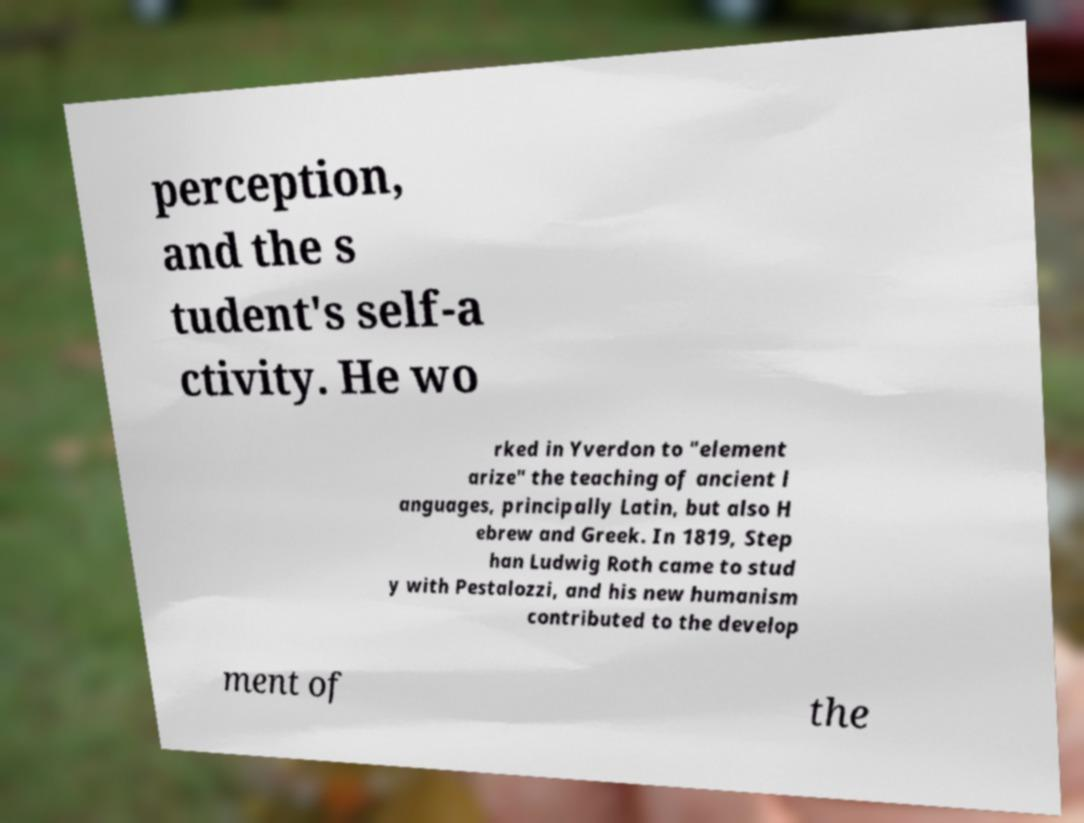I need the written content from this picture converted into text. Can you do that? perception, and the s tudent's self-a ctivity. He wo rked in Yverdon to "element arize" the teaching of ancient l anguages, principally Latin, but also H ebrew and Greek. In 1819, Step han Ludwig Roth came to stud y with Pestalozzi, and his new humanism contributed to the develop ment of the 